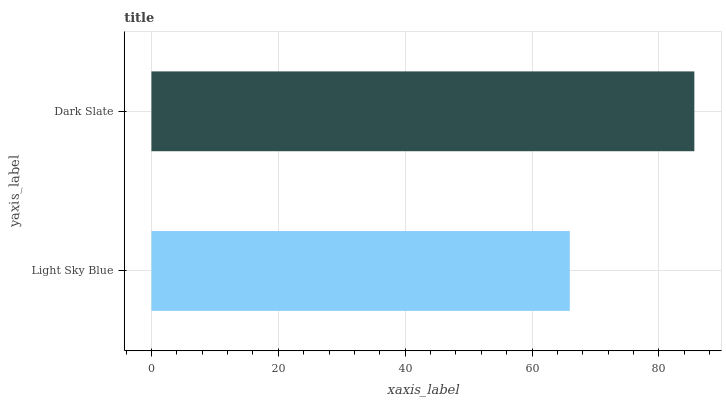Is Light Sky Blue the minimum?
Answer yes or no. Yes. Is Dark Slate the maximum?
Answer yes or no. Yes. Is Dark Slate the minimum?
Answer yes or no. No. Is Dark Slate greater than Light Sky Blue?
Answer yes or no. Yes. Is Light Sky Blue less than Dark Slate?
Answer yes or no. Yes. Is Light Sky Blue greater than Dark Slate?
Answer yes or no. No. Is Dark Slate less than Light Sky Blue?
Answer yes or no. No. Is Dark Slate the high median?
Answer yes or no. Yes. Is Light Sky Blue the low median?
Answer yes or no. Yes. Is Light Sky Blue the high median?
Answer yes or no. No. Is Dark Slate the low median?
Answer yes or no. No. 